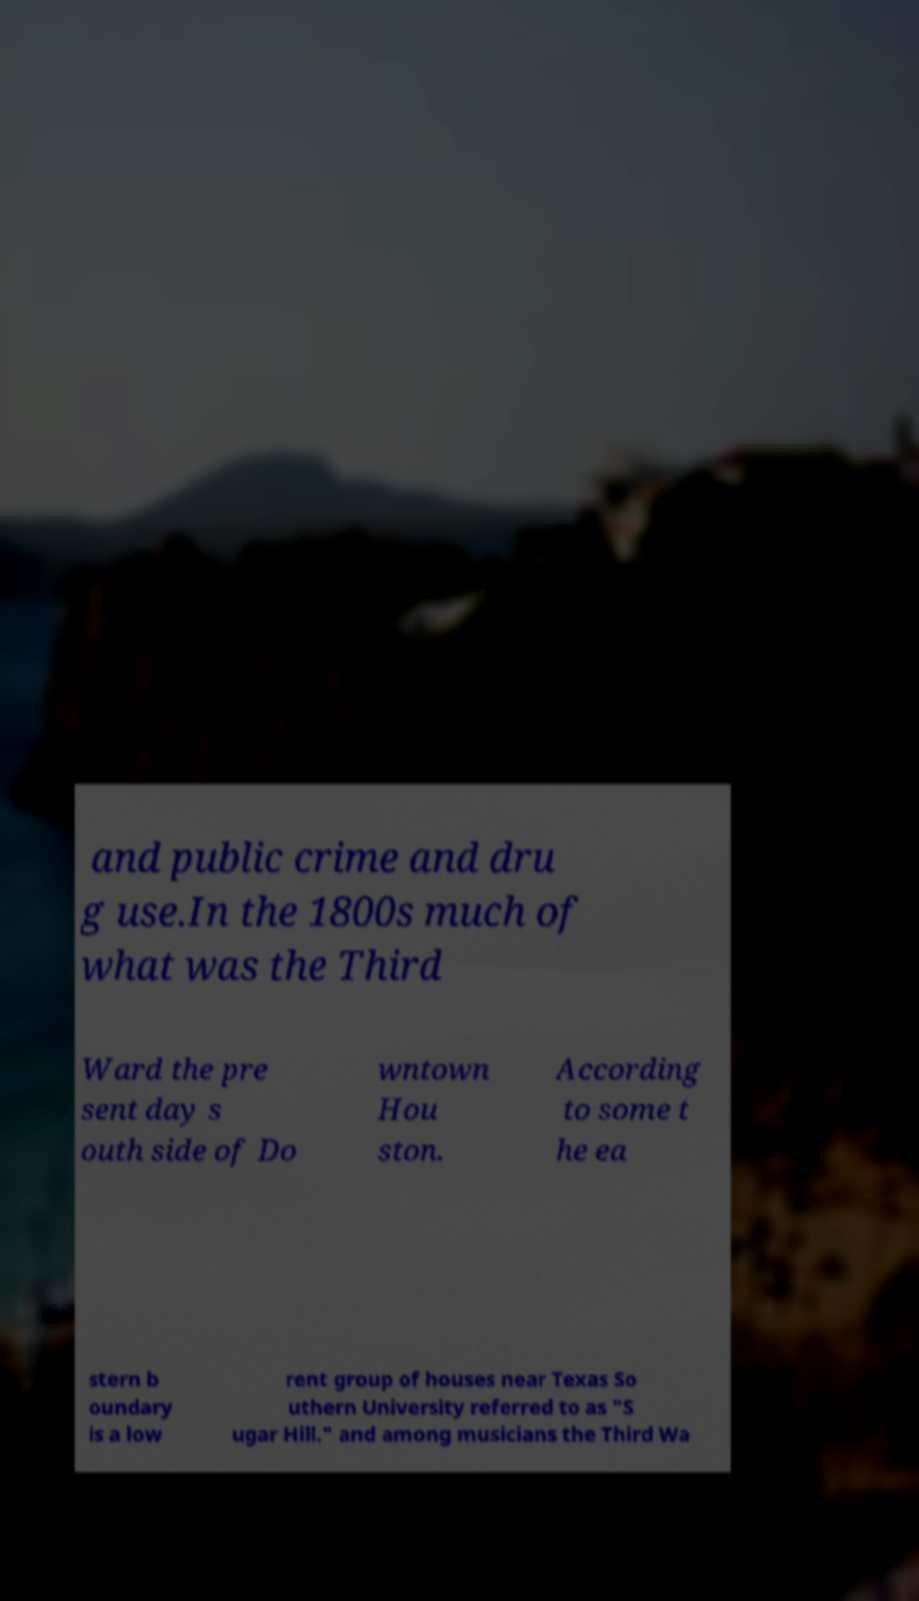Could you assist in decoding the text presented in this image and type it out clearly? and public crime and dru g use.In the 1800s much of what was the Third Ward the pre sent day s outh side of Do wntown Hou ston. According to some t he ea stern b oundary is a low rent group of houses near Texas So uthern University referred to as "S ugar Hill." and among musicians the Third Wa 